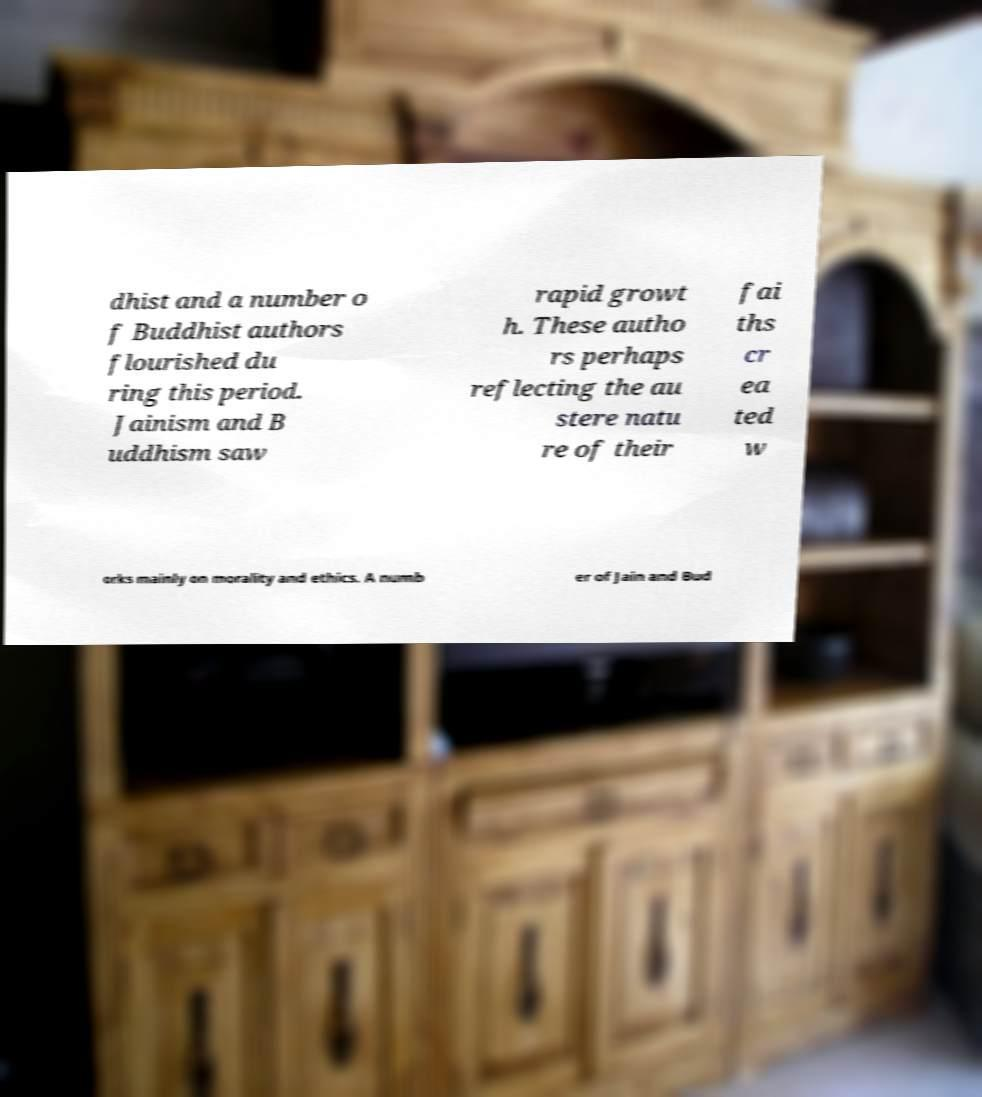I need the written content from this picture converted into text. Can you do that? dhist and a number o f Buddhist authors flourished du ring this period. Jainism and B uddhism saw rapid growt h. These autho rs perhaps reflecting the au stere natu re of their fai ths cr ea ted w orks mainly on morality and ethics. A numb er of Jain and Bud 